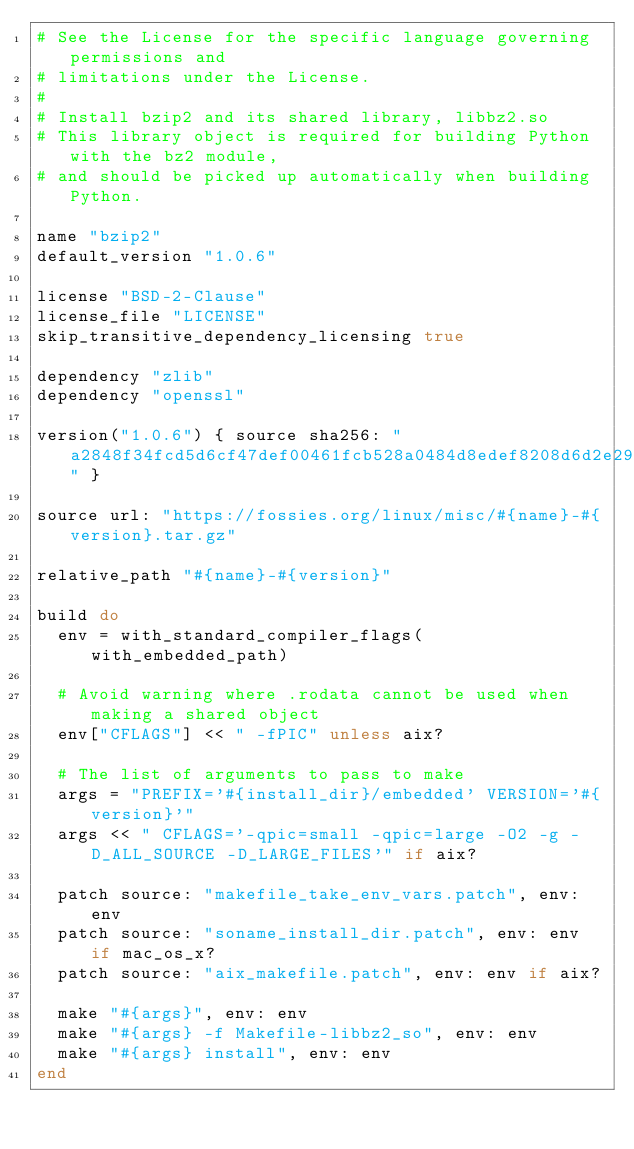<code> <loc_0><loc_0><loc_500><loc_500><_Ruby_># See the License for the specific language governing permissions and
# limitations under the License.
#
# Install bzip2 and its shared library, libbz2.so
# This library object is required for building Python with the bz2 module,
# and should be picked up automatically when building Python.

name "bzip2"
default_version "1.0.6"

license "BSD-2-Clause"
license_file "LICENSE"
skip_transitive_dependency_licensing true

dependency "zlib"
dependency "openssl"

version("1.0.6") { source sha256: "a2848f34fcd5d6cf47def00461fcb528a0484d8edef8208d6d2e2909dc61d9cd" }

source url: "https://fossies.org/linux/misc/#{name}-#{version}.tar.gz"

relative_path "#{name}-#{version}"

build do
  env = with_standard_compiler_flags(with_embedded_path)

  # Avoid warning where .rodata cannot be used when making a shared object
  env["CFLAGS"] << " -fPIC" unless aix?

  # The list of arguments to pass to make
  args = "PREFIX='#{install_dir}/embedded' VERSION='#{version}'"
  args << " CFLAGS='-qpic=small -qpic=large -O2 -g -D_ALL_SOURCE -D_LARGE_FILES'" if aix?

  patch source: "makefile_take_env_vars.patch", env: env
  patch source: "soname_install_dir.patch", env: env if mac_os_x?
  patch source: "aix_makefile.patch", env: env if aix?

  make "#{args}", env: env
  make "#{args} -f Makefile-libbz2_so", env: env
  make "#{args} install", env: env
end
</code> 